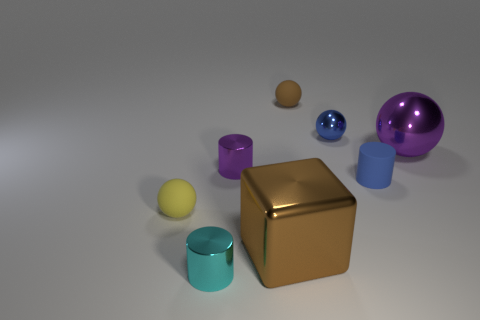There is a small metal cylinder that is behind the small yellow matte thing; what color is it?
Provide a short and direct response. Purple. What is the size of the brown sphere that is the same material as the yellow sphere?
Provide a succinct answer. Small. There is a purple shiny object that is to the right of the brown block; how many large shiny objects are on the left side of it?
Keep it short and to the point. 1. There is a brown block; how many cyan objects are behind it?
Your answer should be compact. 0. There is a rubber object left of the rubber sphere behind the matte sphere that is in front of the tiny brown sphere; what is its color?
Your answer should be compact. Yellow. Is the color of the cylinder that is in front of the large cube the same as the sphere that is right of the blue rubber thing?
Your answer should be compact. No. What is the shape of the brown object that is in front of the purple thing left of the small blue shiny thing?
Ensure brevity in your answer.  Cube. Are there any purple cylinders of the same size as the brown metallic thing?
Ensure brevity in your answer.  No. What number of other small metal things are the same shape as the small cyan metallic object?
Ensure brevity in your answer.  1. Are there the same number of matte cylinders in front of the big shiny block and metallic blocks that are on the left side of the small purple shiny cylinder?
Offer a terse response. Yes. 